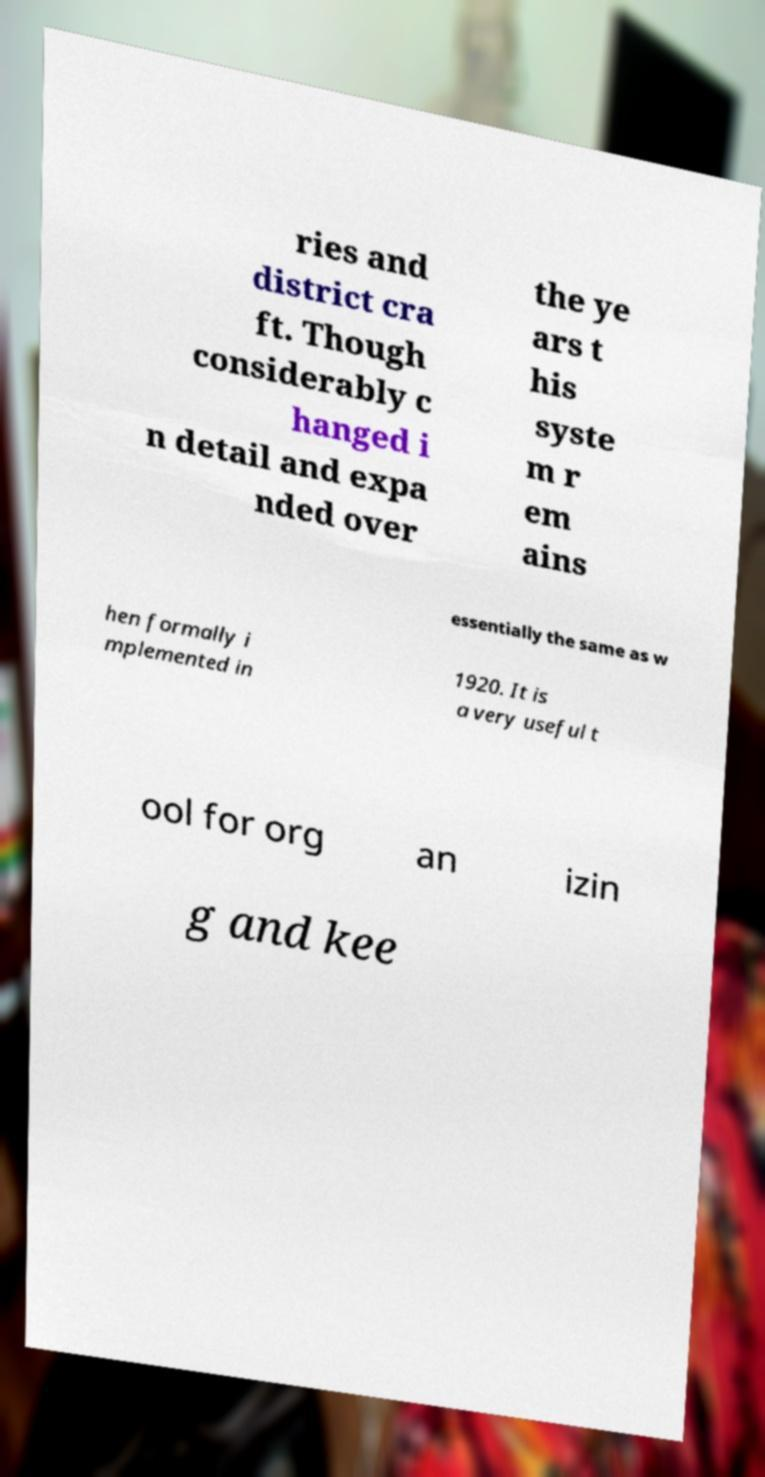Can you accurately transcribe the text from the provided image for me? ries and district cra ft. Though considerably c hanged i n detail and expa nded over the ye ars t his syste m r em ains essentially the same as w hen formally i mplemented in 1920. It is a very useful t ool for org an izin g and kee 